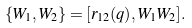<formula> <loc_0><loc_0><loc_500><loc_500>\{ W _ { 1 } , W _ { 2 } \} = [ r _ { 1 2 } ( q ) , W _ { 1 } W _ { 2 } ] .</formula> 